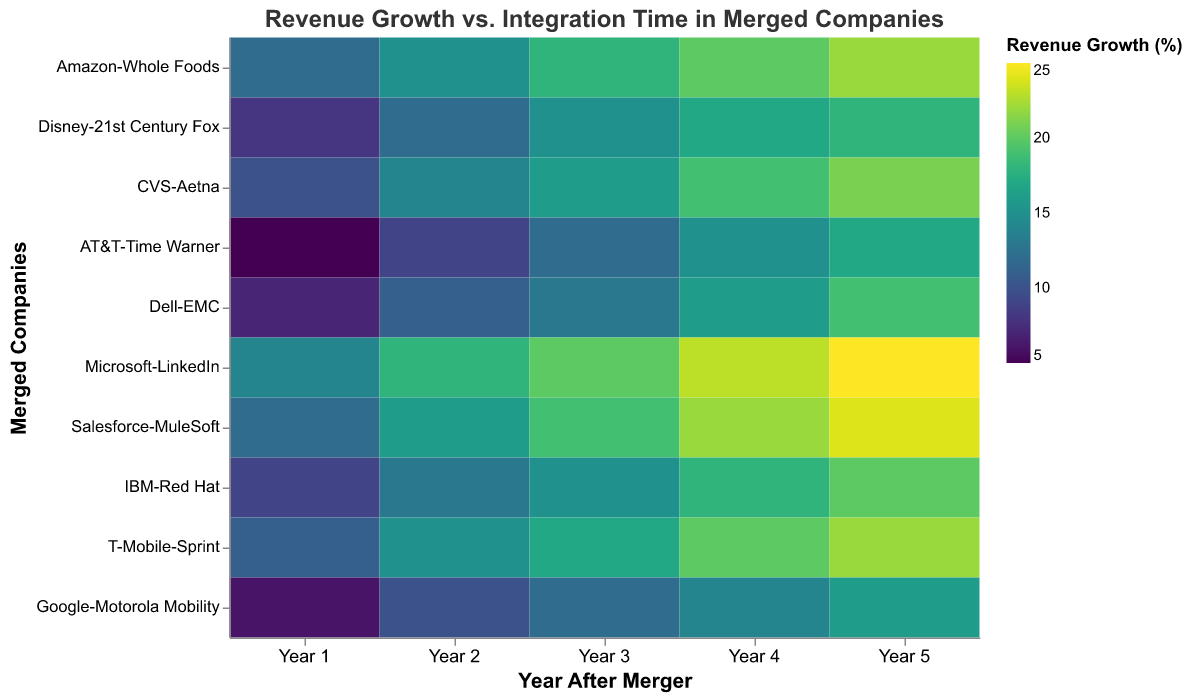Which company had the highest revenue growth in Year 5? Look at the color intensity in Year 5 for each company. Microsoft-LinkedIn has the highest value with 25%.
Answer: Microsoft-LinkedIn Compare the revenue growth of Amazon-Whole Foods and Salesforce-MuleSoft in Year 1. Which is higher? Find both companies in Year 1 and compare their percentages. Amazon-Whole Foods has 12% growth, whereas Salesforce-MuleSoft has 12% growth. They are equal.
Answer: They are equal Which company had the most prolonged integration time and what was it? Check the tooltip or the y-axis labels for the integration times. Disney-21st Century Fox has the longest integration time with 36 months.
Answer: Disney-21st Century Fox, 36 months What's the average revenue growth for CVS-Aetna over the five years? Sum CVS-Aetna's growth percentages over five years (10% + 14% + 16% + 19% + 21%) and divide by 5. (10 + 14 + 16 + 19 + 21) / 5 = 16%
Answer: 16% Which two companies had the closest revenue growth percentage in Year 3? Compare Year 3 growth values for all companies. Dell-EMC and IBM-Red Hat both had 15%.
Answer: Dell-EMC and IBM-Red Hat What was the integration time for Google-Motorola Mobility, and how did their revenue growth change from Year 1 to Year 5? Google-Motorola Mobility had an integration time of 27 months. Their revenue growth went from 6% in Year 1 to 16% in Year 5, an increase of 10 percentage points.
Answer: 27 months; increased by 10 percentage points How does the revenue growth trend of AT&T-Time Warner compare to that of T-Mobile-Sprint? Look at the color gradient for each company from Year 1 to Year 5. Both companies show a gradual increase in revenue growth over the five years. T-Mobile-Sprint starts higher at 11% and ends at 22%, whereas AT&T-Time Warner starts at 5% and ends at 17%.
Answer: Both show a gradual increase; T-Mobile-Sprint has higher values overall What is the median integration time among all companies? Arrange the integration times (22, 24, 26, 27, 28, 29, 30, 31, 33, 36) and find the median. With 10 values, the median is the average of the 5th and 6th values: (28 + 29) / 2 = 28.5 months.
Answer: 28.5 months 